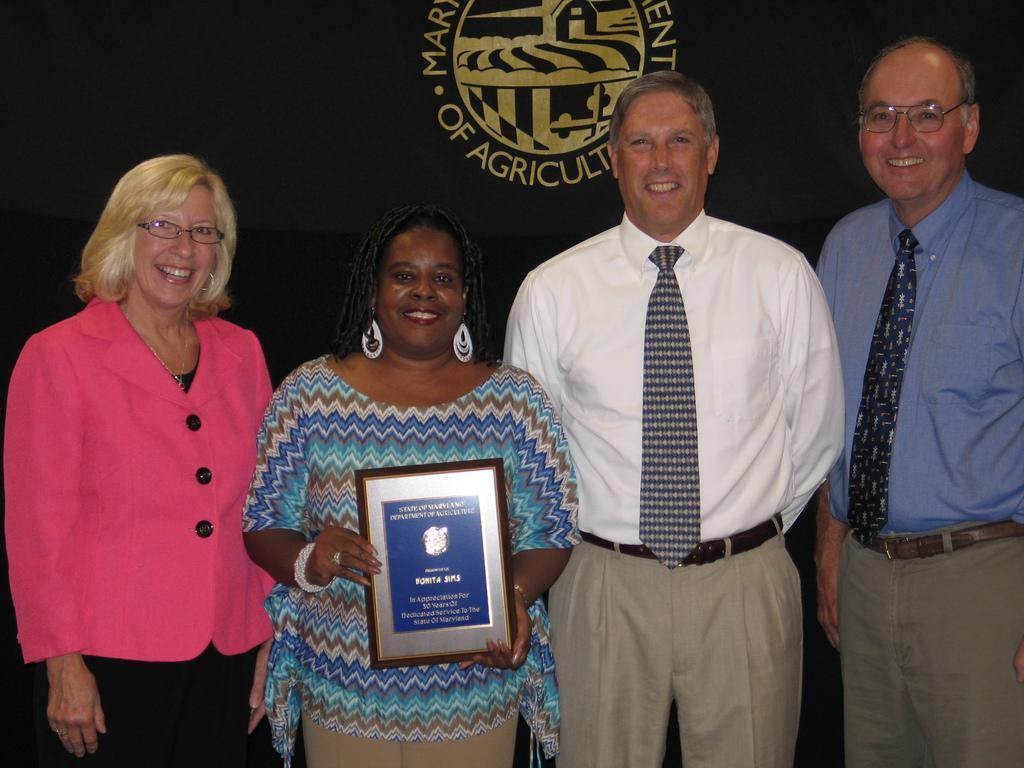Describe this image in one or two sentences. As we can see in the image there are four people standing. The woman over here is holding a photo frame. Behind them there is a banner. 